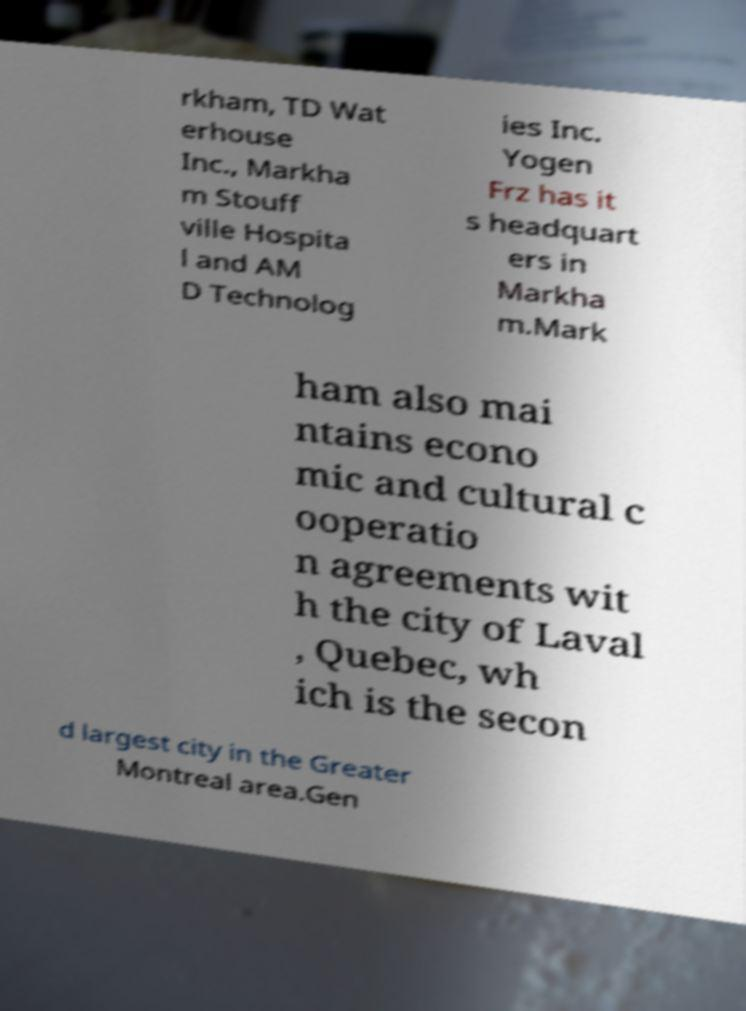What messages or text are displayed in this image? I need them in a readable, typed format. rkham, TD Wat erhouse Inc., Markha m Stouff ville Hospita l and AM D Technolog ies Inc. Yogen Frz has it s headquart ers in Markha m.Mark ham also mai ntains econo mic and cultural c ooperatio n agreements wit h the city of Laval , Quebec, wh ich is the secon d largest city in the Greater Montreal area.Gen 